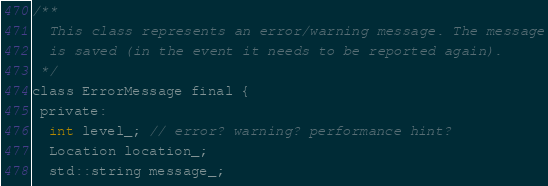Convert code to text. <code><loc_0><loc_0><loc_500><loc_500><_C_>/**
  This class represents an error/warning message. The message
  is saved (in the event it needs to be reported again).
 */
class ErrorMessage final {
 private:
  int level_; // error? warning? performance hint?
  Location location_;
  std::string message_;</code> 